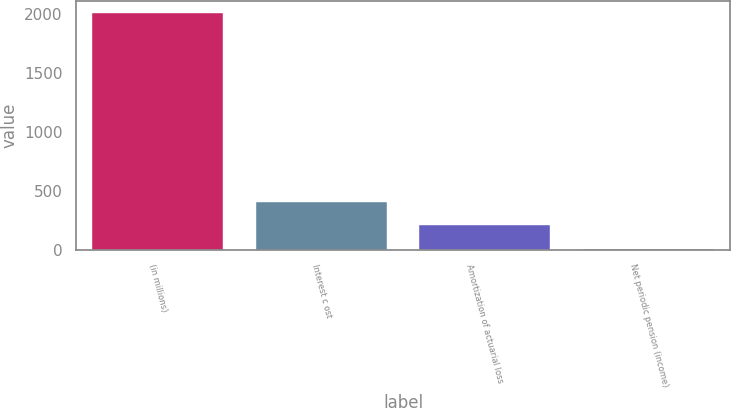Convert chart. <chart><loc_0><loc_0><loc_500><loc_500><bar_chart><fcel>(in millions)<fcel>Interest c ost<fcel>Amortization of actuarial loss<fcel>Net periodic pension (income)<nl><fcel>2014<fcel>409.2<fcel>208.6<fcel>8<nl></chart> 